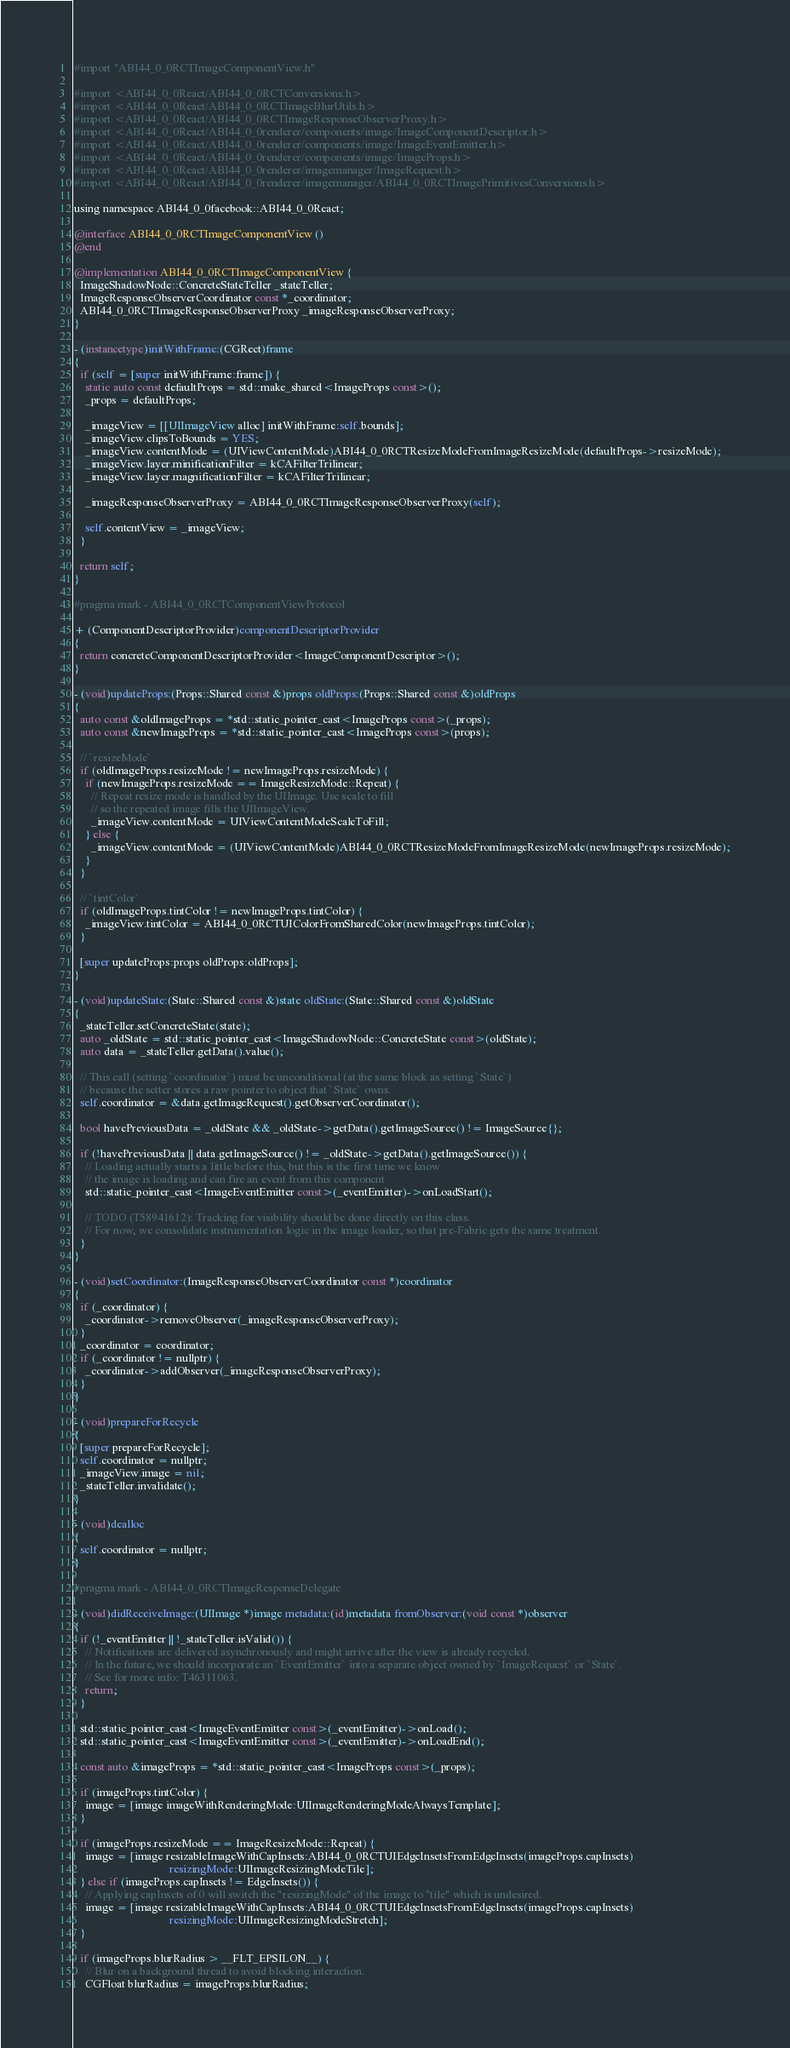<code> <loc_0><loc_0><loc_500><loc_500><_ObjectiveC_>
#import "ABI44_0_0RCTImageComponentView.h"

#import <ABI44_0_0React/ABI44_0_0RCTConversions.h>
#import <ABI44_0_0React/ABI44_0_0RCTImageBlurUtils.h>
#import <ABI44_0_0React/ABI44_0_0RCTImageResponseObserverProxy.h>
#import <ABI44_0_0React/ABI44_0_0renderer/components/image/ImageComponentDescriptor.h>
#import <ABI44_0_0React/ABI44_0_0renderer/components/image/ImageEventEmitter.h>
#import <ABI44_0_0React/ABI44_0_0renderer/components/image/ImageProps.h>
#import <ABI44_0_0React/ABI44_0_0renderer/imagemanager/ImageRequest.h>
#import <ABI44_0_0React/ABI44_0_0renderer/imagemanager/ABI44_0_0RCTImagePrimitivesConversions.h>

using namespace ABI44_0_0facebook::ABI44_0_0React;

@interface ABI44_0_0RCTImageComponentView ()
@end

@implementation ABI44_0_0RCTImageComponentView {
  ImageShadowNode::ConcreteStateTeller _stateTeller;
  ImageResponseObserverCoordinator const *_coordinator;
  ABI44_0_0RCTImageResponseObserverProxy _imageResponseObserverProxy;
}

- (instancetype)initWithFrame:(CGRect)frame
{
  if (self = [super initWithFrame:frame]) {
    static auto const defaultProps = std::make_shared<ImageProps const>();
    _props = defaultProps;

    _imageView = [[UIImageView alloc] initWithFrame:self.bounds];
    _imageView.clipsToBounds = YES;
    _imageView.contentMode = (UIViewContentMode)ABI44_0_0RCTResizeModeFromImageResizeMode(defaultProps->resizeMode);
    _imageView.layer.minificationFilter = kCAFilterTrilinear;
    _imageView.layer.magnificationFilter = kCAFilterTrilinear;

    _imageResponseObserverProxy = ABI44_0_0RCTImageResponseObserverProxy(self);

    self.contentView = _imageView;
  }

  return self;
}

#pragma mark - ABI44_0_0RCTComponentViewProtocol

+ (ComponentDescriptorProvider)componentDescriptorProvider
{
  return concreteComponentDescriptorProvider<ImageComponentDescriptor>();
}

- (void)updateProps:(Props::Shared const &)props oldProps:(Props::Shared const &)oldProps
{
  auto const &oldImageProps = *std::static_pointer_cast<ImageProps const>(_props);
  auto const &newImageProps = *std::static_pointer_cast<ImageProps const>(props);

  // `resizeMode`
  if (oldImageProps.resizeMode != newImageProps.resizeMode) {
    if (newImageProps.resizeMode == ImageResizeMode::Repeat) {
      // Repeat resize mode is handled by the UIImage. Use scale to fill
      // so the repeated image fills the UIImageView.
      _imageView.contentMode = UIViewContentModeScaleToFill;
    } else {
      _imageView.contentMode = (UIViewContentMode)ABI44_0_0RCTResizeModeFromImageResizeMode(newImageProps.resizeMode);
    }
  }

  // `tintColor`
  if (oldImageProps.tintColor != newImageProps.tintColor) {
    _imageView.tintColor = ABI44_0_0RCTUIColorFromSharedColor(newImageProps.tintColor);
  }

  [super updateProps:props oldProps:oldProps];
}

- (void)updateState:(State::Shared const &)state oldState:(State::Shared const &)oldState
{
  _stateTeller.setConcreteState(state);
  auto _oldState = std::static_pointer_cast<ImageShadowNode::ConcreteState const>(oldState);
  auto data = _stateTeller.getData().value();

  // This call (setting `coordinator`) must be unconditional (at the same block as setting `State`)
  // because the setter stores a raw pointer to object that `State` owns.
  self.coordinator = &data.getImageRequest().getObserverCoordinator();

  bool havePreviousData = _oldState && _oldState->getData().getImageSource() != ImageSource{};

  if (!havePreviousData || data.getImageSource() != _oldState->getData().getImageSource()) {
    // Loading actually starts a little before this, but this is the first time we know
    // the image is loading and can fire an event from this component
    std::static_pointer_cast<ImageEventEmitter const>(_eventEmitter)->onLoadStart();

    // TODO (T58941612): Tracking for visibility should be done directly on this class.
    // For now, we consolidate instrumentation logic in the image loader, so that pre-Fabric gets the same treatment.
  }
}

- (void)setCoordinator:(ImageResponseObserverCoordinator const *)coordinator
{
  if (_coordinator) {
    _coordinator->removeObserver(_imageResponseObserverProxy);
  }
  _coordinator = coordinator;
  if (_coordinator != nullptr) {
    _coordinator->addObserver(_imageResponseObserverProxy);
  }
}

- (void)prepareForRecycle
{
  [super prepareForRecycle];
  self.coordinator = nullptr;
  _imageView.image = nil;
  _stateTeller.invalidate();
}

- (void)dealloc
{
  self.coordinator = nullptr;
}

#pragma mark - ABI44_0_0RCTImageResponseDelegate

- (void)didReceiveImage:(UIImage *)image metadata:(id)metadata fromObserver:(void const *)observer
{
  if (!_eventEmitter || !_stateTeller.isValid()) {
    // Notifications are delivered asynchronously and might arrive after the view is already recycled.
    // In the future, we should incorporate an `EventEmitter` into a separate object owned by `ImageRequest` or `State`.
    // See for more info: T46311063.
    return;
  }

  std::static_pointer_cast<ImageEventEmitter const>(_eventEmitter)->onLoad();
  std::static_pointer_cast<ImageEventEmitter const>(_eventEmitter)->onLoadEnd();

  const auto &imageProps = *std::static_pointer_cast<ImageProps const>(_props);

  if (imageProps.tintColor) {
    image = [image imageWithRenderingMode:UIImageRenderingModeAlwaysTemplate];
  }

  if (imageProps.resizeMode == ImageResizeMode::Repeat) {
    image = [image resizableImageWithCapInsets:ABI44_0_0RCTUIEdgeInsetsFromEdgeInsets(imageProps.capInsets)
                                  resizingMode:UIImageResizingModeTile];
  } else if (imageProps.capInsets != EdgeInsets()) {
    // Applying capInsets of 0 will switch the "resizingMode" of the image to "tile" which is undesired.
    image = [image resizableImageWithCapInsets:ABI44_0_0RCTUIEdgeInsetsFromEdgeInsets(imageProps.capInsets)
                                  resizingMode:UIImageResizingModeStretch];
  }

  if (imageProps.blurRadius > __FLT_EPSILON__) {
    // Blur on a background thread to avoid blocking interaction.
    CGFloat blurRadius = imageProps.blurRadius;</code> 